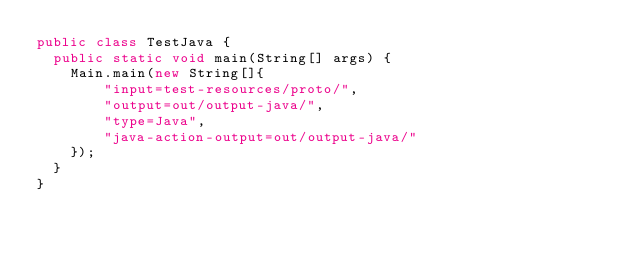Convert code to text. <code><loc_0><loc_0><loc_500><loc_500><_Java_>public class TestJava {
	public static void main(String[] args) {
		Main.main(new String[]{
				"input=test-resources/proto/",
				"output=out/output-java/",
				"type=Java",
				"java-action-output=out/output-java/"
		});
	}
}
</code> 